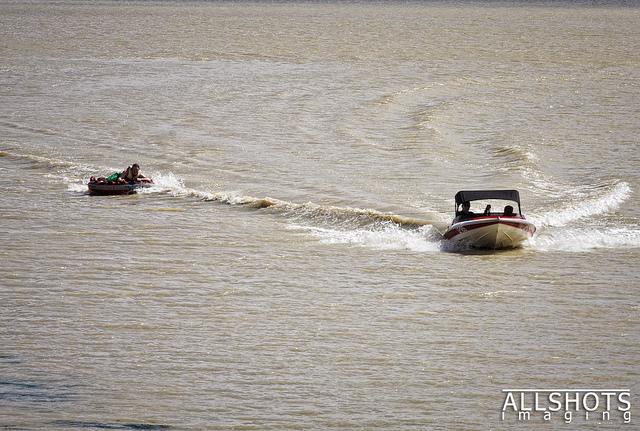What is the photo written?
Quick response, please. Allshots imaging. How many boats are shown?
Answer briefly. 1. What is on the water?
Short answer required. Boat. 